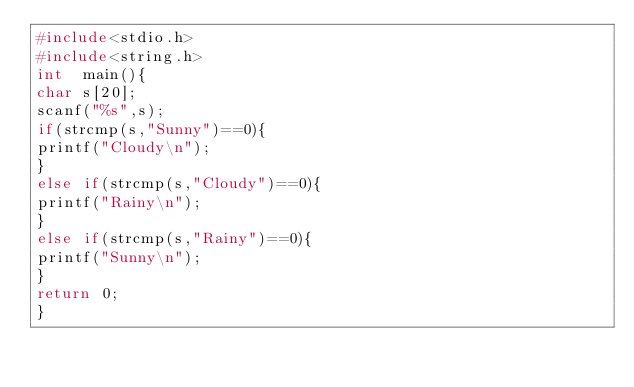<code> <loc_0><loc_0><loc_500><loc_500><_C_>#include<stdio.h>
#include<string.h>
int  main(){
char s[20];
scanf("%s",s);
if(strcmp(s,"Sunny")==0){
printf("Cloudy\n");
}
else if(strcmp(s,"Cloudy")==0){
printf("Rainy\n");
}
else if(strcmp(s,"Rainy")==0){
printf("Sunny\n");
}
return 0;
}</code> 